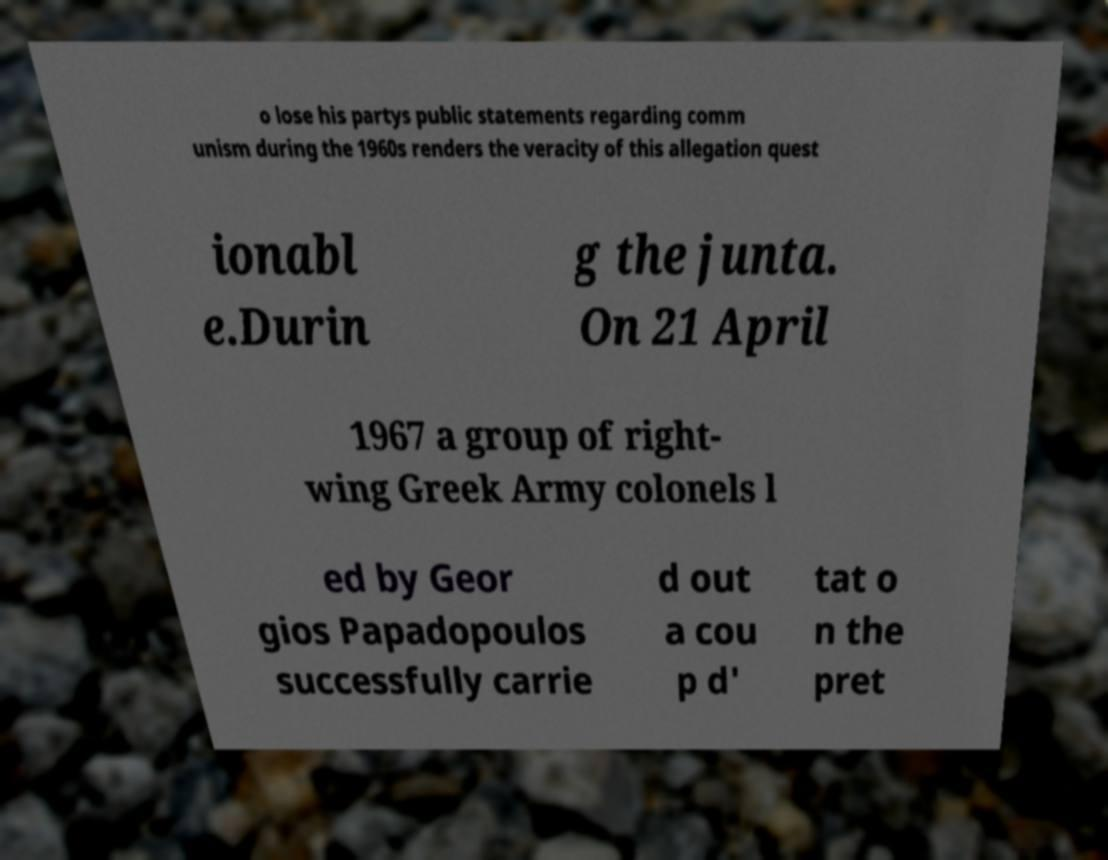There's text embedded in this image that I need extracted. Can you transcribe it verbatim? o lose his partys public statements regarding comm unism during the 1960s renders the veracity of this allegation quest ionabl e.Durin g the junta. On 21 April 1967 a group of right- wing Greek Army colonels l ed by Geor gios Papadopoulos successfully carrie d out a cou p d' tat o n the pret 